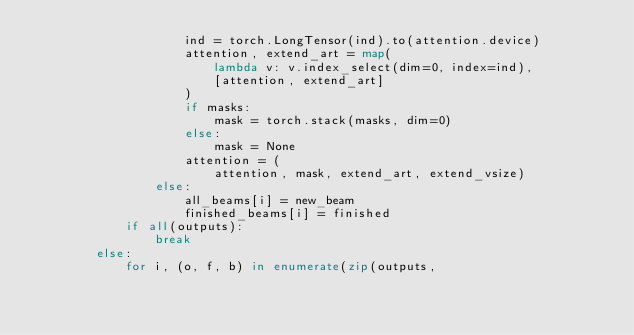Convert code to text. <code><loc_0><loc_0><loc_500><loc_500><_Python_>                    ind = torch.LongTensor(ind).to(attention.device)
                    attention, extend_art = map(
                        lambda v: v.index_select(dim=0, index=ind),
                        [attention, extend_art]
                    )
                    if masks:
                        mask = torch.stack(masks, dim=0)
                    else:
                        mask = None
                    attention = (
                        attention, mask, extend_art, extend_vsize)
                else:
                    all_beams[i] = new_beam
                    finished_beams[i] = finished
            if all(outputs):
                break
        else:
            for i, (o, f, b) in enumerate(zip(outputs,</code> 